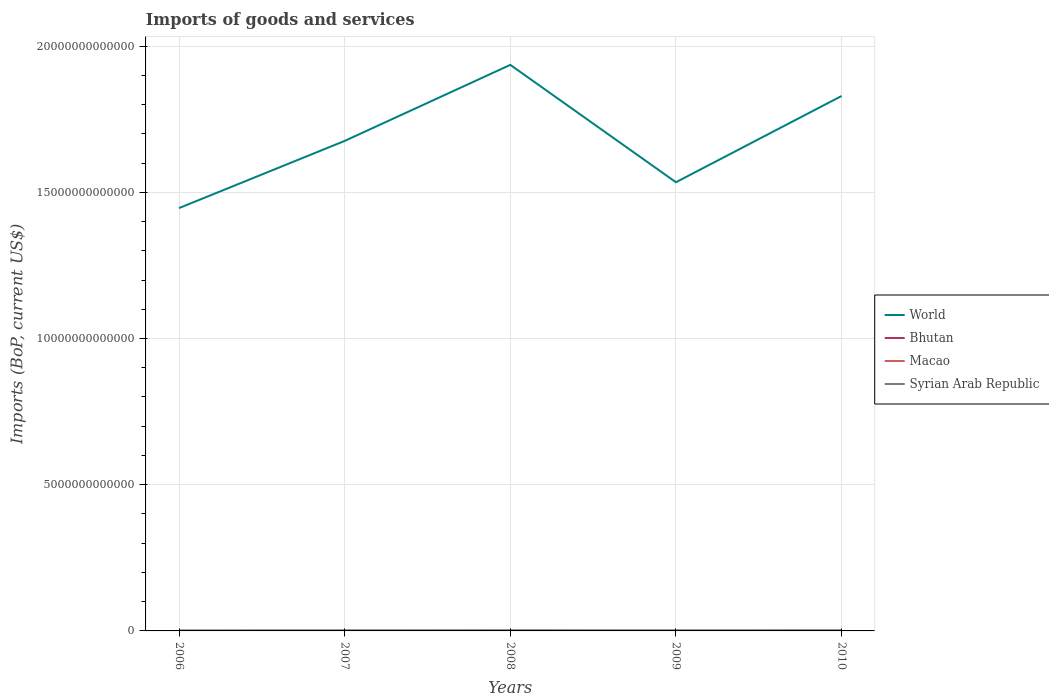How many different coloured lines are there?
Your response must be concise. 4. Does the line corresponding to Syrian Arab Republic intersect with the line corresponding to Macao?
Make the answer very short. No. Is the number of lines equal to the number of legend labels?
Offer a terse response. Yes. Across all years, what is the maximum amount spent on imports in Syrian Arab Republic?
Give a very brief answer. 1.19e+1. In which year was the amount spent on imports in Bhutan maximum?
Provide a succinct answer. 2006. What is the total amount spent on imports in Macao in the graph?
Give a very brief answer. -1.22e+09. What is the difference between the highest and the second highest amount spent on imports in Bhutan?
Keep it short and to the point. 4.36e+08. What is the difference between the highest and the lowest amount spent on imports in Macao?
Provide a short and direct response. 3. What is the difference between two consecutive major ticks on the Y-axis?
Offer a terse response. 5.00e+12. Does the graph contain any zero values?
Your answer should be compact. No. Where does the legend appear in the graph?
Keep it short and to the point. Center right. What is the title of the graph?
Provide a short and direct response. Imports of goods and services. Does "Virgin Islands" appear as one of the legend labels in the graph?
Ensure brevity in your answer.  No. What is the label or title of the Y-axis?
Give a very brief answer. Imports (BoP, current US$). What is the Imports (BoP, current US$) in World in 2006?
Keep it short and to the point. 1.45e+13. What is the Imports (BoP, current US$) of Bhutan in 2006?
Your answer should be compact. 4.99e+08. What is the Imports (BoP, current US$) in Macao in 2006?
Offer a very short reply. 8.92e+09. What is the Imports (BoP, current US$) of Syrian Arab Republic in 2006?
Ensure brevity in your answer.  1.19e+1. What is the Imports (BoP, current US$) of World in 2007?
Ensure brevity in your answer.  1.68e+13. What is the Imports (BoP, current US$) of Bhutan in 2007?
Your answer should be compact. 5.86e+08. What is the Imports (BoP, current US$) of Macao in 2007?
Give a very brief answer. 1.19e+1. What is the Imports (BoP, current US$) in Syrian Arab Republic in 2007?
Your answer should be very brief. 1.53e+1. What is the Imports (BoP, current US$) of World in 2008?
Ensure brevity in your answer.  1.94e+13. What is the Imports (BoP, current US$) in Bhutan in 2008?
Ensure brevity in your answer.  7.66e+08. What is the Imports (BoP, current US$) of Macao in 2008?
Keep it short and to the point. 1.31e+1. What is the Imports (BoP, current US$) of Syrian Arab Republic in 2008?
Make the answer very short. 1.93e+1. What is the Imports (BoP, current US$) of World in 2009?
Your answer should be very brief. 1.53e+13. What is the Imports (BoP, current US$) of Bhutan in 2009?
Give a very brief answer. 6.82e+08. What is the Imports (BoP, current US$) of Macao in 2009?
Offer a very short reply. 1.06e+1. What is the Imports (BoP, current US$) in Syrian Arab Republic in 2009?
Your answer should be compact. 1.67e+1. What is the Imports (BoP, current US$) of World in 2010?
Keep it short and to the point. 1.83e+13. What is the Imports (BoP, current US$) of Bhutan in 2010?
Give a very brief answer. 9.35e+08. What is the Imports (BoP, current US$) of Macao in 2010?
Make the answer very short. 1.41e+1. What is the Imports (BoP, current US$) of Syrian Arab Republic in 2010?
Your answer should be very brief. 1.94e+1. Across all years, what is the maximum Imports (BoP, current US$) in World?
Provide a succinct answer. 1.94e+13. Across all years, what is the maximum Imports (BoP, current US$) in Bhutan?
Give a very brief answer. 9.35e+08. Across all years, what is the maximum Imports (BoP, current US$) of Macao?
Provide a short and direct response. 1.41e+1. Across all years, what is the maximum Imports (BoP, current US$) of Syrian Arab Republic?
Offer a terse response. 1.94e+1. Across all years, what is the minimum Imports (BoP, current US$) in World?
Provide a short and direct response. 1.45e+13. Across all years, what is the minimum Imports (BoP, current US$) of Bhutan?
Offer a very short reply. 4.99e+08. Across all years, what is the minimum Imports (BoP, current US$) in Macao?
Your response must be concise. 8.92e+09. Across all years, what is the minimum Imports (BoP, current US$) of Syrian Arab Republic?
Offer a very short reply. 1.19e+1. What is the total Imports (BoP, current US$) in World in the graph?
Ensure brevity in your answer.  8.42e+13. What is the total Imports (BoP, current US$) in Bhutan in the graph?
Your answer should be compact. 3.47e+09. What is the total Imports (BoP, current US$) of Macao in the graph?
Give a very brief answer. 5.86e+1. What is the total Imports (BoP, current US$) of Syrian Arab Republic in the graph?
Offer a terse response. 8.25e+1. What is the difference between the Imports (BoP, current US$) in World in 2006 and that in 2007?
Your answer should be very brief. -2.30e+12. What is the difference between the Imports (BoP, current US$) of Bhutan in 2006 and that in 2007?
Ensure brevity in your answer.  -8.69e+07. What is the difference between the Imports (BoP, current US$) of Macao in 2006 and that in 2007?
Ensure brevity in your answer.  -2.97e+09. What is the difference between the Imports (BoP, current US$) of Syrian Arab Republic in 2006 and that in 2007?
Provide a short and direct response. -3.41e+09. What is the difference between the Imports (BoP, current US$) in World in 2006 and that in 2008?
Make the answer very short. -4.90e+12. What is the difference between the Imports (BoP, current US$) of Bhutan in 2006 and that in 2008?
Provide a short and direct response. -2.66e+08. What is the difference between the Imports (BoP, current US$) of Macao in 2006 and that in 2008?
Provide a short and direct response. -4.19e+09. What is the difference between the Imports (BoP, current US$) in Syrian Arab Republic in 2006 and that in 2008?
Give a very brief answer. -7.40e+09. What is the difference between the Imports (BoP, current US$) of World in 2006 and that in 2009?
Provide a short and direct response. -8.84e+11. What is the difference between the Imports (BoP, current US$) in Bhutan in 2006 and that in 2009?
Make the answer very short. -1.83e+08. What is the difference between the Imports (BoP, current US$) in Macao in 2006 and that in 2009?
Your answer should be very brief. -1.65e+09. What is the difference between the Imports (BoP, current US$) of Syrian Arab Republic in 2006 and that in 2009?
Ensure brevity in your answer.  -4.79e+09. What is the difference between the Imports (BoP, current US$) in World in 2006 and that in 2010?
Make the answer very short. -3.83e+12. What is the difference between the Imports (BoP, current US$) of Bhutan in 2006 and that in 2010?
Your response must be concise. -4.36e+08. What is the difference between the Imports (BoP, current US$) in Macao in 2006 and that in 2010?
Ensure brevity in your answer.  -5.21e+09. What is the difference between the Imports (BoP, current US$) of Syrian Arab Republic in 2006 and that in 2010?
Offer a very short reply. -7.53e+09. What is the difference between the Imports (BoP, current US$) in World in 2007 and that in 2008?
Ensure brevity in your answer.  -2.60e+12. What is the difference between the Imports (BoP, current US$) of Bhutan in 2007 and that in 2008?
Offer a terse response. -1.79e+08. What is the difference between the Imports (BoP, current US$) of Macao in 2007 and that in 2008?
Give a very brief answer. -1.22e+09. What is the difference between the Imports (BoP, current US$) in Syrian Arab Republic in 2007 and that in 2008?
Keep it short and to the point. -3.99e+09. What is the difference between the Imports (BoP, current US$) of World in 2007 and that in 2009?
Offer a very short reply. 1.41e+12. What is the difference between the Imports (BoP, current US$) in Bhutan in 2007 and that in 2009?
Keep it short and to the point. -9.58e+07. What is the difference between the Imports (BoP, current US$) in Macao in 2007 and that in 2009?
Your answer should be compact. 1.32e+09. What is the difference between the Imports (BoP, current US$) of Syrian Arab Republic in 2007 and that in 2009?
Give a very brief answer. -1.38e+09. What is the difference between the Imports (BoP, current US$) of World in 2007 and that in 2010?
Your answer should be compact. -1.54e+12. What is the difference between the Imports (BoP, current US$) in Bhutan in 2007 and that in 2010?
Provide a short and direct response. -3.49e+08. What is the difference between the Imports (BoP, current US$) in Macao in 2007 and that in 2010?
Offer a very short reply. -2.24e+09. What is the difference between the Imports (BoP, current US$) of Syrian Arab Republic in 2007 and that in 2010?
Provide a succinct answer. -4.12e+09. What is the difference between the Imports (BoP, current US$) of World in 2008 and that in 2009?
Provide a succinct answer. 4.01e+12. What is the difference between the Imports (BoP, current US$) of Bhutan in 2008 and that in 2009?
Make the answer very short. 8.35e+07. What is the difference between the Imports (BoP, current US$) of Macao in 2008 and that in 2009?
Make the answer very short. 2.55e+09. What is the difference between the Imports (BoP, current US$) in Syrian Arab Republic in 2008 and that in 2009?
Provide a short and direct response. 2.61e+09. What is the difference between the Imports (BoP, current US$) in World in 2008 and that in 2010?
Your answer should be compact. 1.06e+12. What is the difference between the Imports (BoP, current US$) in Bhutan in 2008 and that in 2010?
Your answer should be compact. -1.70e+08. What is the difference between the Imports (BoP, current US$) of Macao in 2008 and that in 2010?
Your response must be concise. -1.01e+09. What is the difference between the Imports (BoP, current US$) of Syrian Arab Republic in 2008 and that in 2010?
Ensure brevity in your answer.  -1.30e+08. What is the difference between the Imports (BoP, current US$) of World in 2009 and that in 2010?
Make the answer very short. -2.95e+12. What is the difference between the Imports (BoP, current US$) of Bhutan in 2009 and that in 2010?
Provide a short and direct response. -2.53e+08. What is the difference between the Imports (BoP, current US$) of Macao in 2009 and that in 2010?
Your answer should be very brief. -3.56e+09. What is the difference between the Imports (BoP, current US$) in Syrian Arab Republic in 2009 and that in 2010?
Make the answer very short. -2.74e+09. What is the difference between the Imports (BoP, current US$) in World in 2006 and the Imports (BoP, current US$) in Bhutan in 2007?
Your answer should be very brief. 1.45e+13. What is the difference between the Imports (BoP, current US$) in World in 2006 and the Imports (BoP, current US$) in Macao in 2007?
Your answer should be compact. 1.44e+13. What is the difference between the Imports (BoP, current US$) of World in 2006 and the Imports (BoP, current US$) of Syrian Arab Republic in 2007?
Provide a short and direct response. 1.44e+13. What is the difference between the Imports (BoP, current US$) in Bhutan in 2006 and the Imports (BoP, current US$) in Macao in 2007?
Provide a short and direct response. -1.14e+1. What is the difference between the Imports (BoP, current US$) in Bhutan in 2006 and the Imports (BoP, current US$) in Syrian Arab Republic in 2007?
Your answer should be very brief. -1.48e+1. What is the difference between the Imports (BoP, current US$) in Macao in 2006 and the Imports (BoP, current US$) in Syrian Arab Republic in 2007?
Your response must be concise. -6.37e+09. What is the difference between the Imports (BoP, current US$) in World in 2006 and the Imports (BoP, current US$) in Bhutan in 2008?
Offer a very short reply. 1.45e+13. What is the difference between the Imports (BoP, current US$) in World in 2006 and the Imports (BoP, current US$) in Macao in 2008?
Give a very brief answer. 1.44e+13. What is the difference between the Imports (BoP, current US$) in World in 2006 and the Imports (BoP, current US$) in Syrian Arab Republic in 2008?
Keep it short and to the point. 1.44e+13. What is the difference between the Imports (BoP, current US$) in Bhutan in 2006 and the Imports (BoP, current US$) in Macao in 2008?
Your answer should be very brief. -1.26e+1. What is the difference between the Imports (BoP, current US$) of Bhutan in 2006 and the Imports (BoP, current US$) of Syrian Arab Republic in 2008?
Make the answer very short. -1.88e+1. What is the difference between the Imports (BoP, current US$) of Macao in 2006 and the Imports (BoP, current US$) of Syrian Arab Republic in 2008?
Keep it short and to the point. -1.04e+1. What is the difference between the Imports (BoP, current US$) in World in 2006 and the Imports (BoP, current US$) in Bhutan in 2009?
Provide a succinct answer. 1.45e+13. What is the difference between the Imports (BoP, current US$) of World in 2006 and the Imports (BoP, current US$) of Macao in 2009?
Provide a short and direct response. 1.44e+13. What is the difference between the Imports (BoP, current US$) of World in 2006 and the Imports (BoP, current US$) of Syrian Arab Republic in 2009?
Your answer should be compact. 1.44e+13. What is the difference between the Imports (BoP, current US$) in Bhutan in 2006 and the Imports (BoP, current US$) in Macao in 2009?
Provide a succinct answer. -1.01e+1. What is the difference between the Imports (BoP, current US$) in Bhutan in 2006 and the Imports (BoP, current US$) in Syrian Arab Republic in 2009?
Your answer should be very brief. -1.62e+1. What is the difference between the Imports (BoP, current US$) in Macao in 2006 and the Imports (BoP, current US$) in Syrian Arab Republic in 2009?
Keep it short and to the point. -7.74e+09. What is the difference between the Imports (BoP, current US$) in World in 2006 and the Imports (BoP, current US$) in Bhutan in 2010?
Offer a very short reply. 1.45e+13. What is the difference between the Imports (BoP, current US$) in World in 2006 and the Imports (BoP, current US$) in Macao in 2010?
Provide a short and direct response. 1.44e+13. What is the difference between the Imports (BoP, current US$) of World in 2006 and the Imports (BoP, current US$) of Syrian Arab Republic in 2010?
Keep it short and to the point. 1.44e+13. What is the difference between the Imports (BoP, current US$) in Bhutan in 2006 and the Imports (BoP, current US$) in Macao in 2010?
Ensure brevity in your answer.  -1.36e+1. What is the difference between the Imports (BoP, current US$) in Bhutan in 2006 and the Imports (BoP, current US$) in Syrian Arab Republic in 2010?
Keep it short and to the point. -1.89e+1. What is the difference between the Imports (BoP, current US$) in Macao in 2006 and the Imports (BoP, current US$) in Syrian Arab Republic in 2010?
Provide a succinct answer. -1.05e+1. What is the difference between the Imports (BoP, current US$) in World in 2007 and the Imports (BoP, current US$) in Bhutan in 2008?
Make the answer very short. 1.68e+13. What is the difference between the Imports (BoP, current US$) of World in 2007 and the Imports (BoP, current US$) of Macao in 2008?
Provide a short and direct response. 1.67e+13. What is the difference between the Imports (BoP, current US$) of World in 2007 and the Imports (BoP, current US$) of Syrian Arab Republic in 2008?
Offer a very short reply. 1.67e+13. What is the difference between the Imports (BoP, current US$) of Bhutan in 2007 and the Imports (BoP, current US$) of Macao in 2008?
Your response must be concise. -1.25e+1. What is the difference between the Imports (BoP, current US$) of Bhutan in 2007 and the Imports (BoP, current US$) of Syrian Arab Republic in 2008?
Provide a succinct answer. -1.87e+1. What is the difference between the Imports (BoP, current US$) of Macao in 2007 and the Imports (BoP, current US$) of Syrian Arab Republic in 2008?
Provide a short and direct response. -7.39e+09. What is the difference between the Imports (BoP, current US$) in World in 2007 and the Imports (BoP, current US$) in Bhutan in 2009?
Your answer should be compact. 1.68e+13. What is the difference between the Imports (BoP, current US$) in World in 2007 and the Imports (BoP, current US$) in Macao in 2009?
Provide a short and direct response. 1.67e+13. What is the difference between the Imports (BoP, current US$) of World in 2007 and the Imports (BoP, current US$) of Syrian Arab Republic in 2009?
Your response must be concise. 1.67e+13. What is the difference between the Imports (BoP, current US$) in Bhutan in 2007 and the Imports (BoP, current US$) in Macao in 2009?
Provide a short and direct response. -9.98e+09. What is the difference between the Imports (BoP, current US$) of Bhutan in 2007 and the Imports (BoP, current US$) of Syrian Arab Republic in 2009?
Ensure brevity in your answer.  -1.61e+1. What is the difference between the Imports (BoP, current US$) of Macao in 2007 and the Imports (BoP, current US$) of Syrian Arab Republic in 2009?
Offer a terse response. -4.77e+09. What is the difference between the Imports (BoP, current US$) in World in 2007 and the Imports (BoP, current US$) in Bhutan in 2010?
Give a very brief answer. 1.68e+13. What is the difference between the Imports (BoP, current US$) in World in 2007 and the Imports (BoP, current US$) in Macao in 2010?
Your answer should be very brief. 1.67e+13. What is the difference between the Imports (BoP, current US$) in World in 2007 and the Imports (BoP, current US$) in Syrian Arab Republic in 2010?
Your answer should be compact. 1.67e+13. What is the difference between the Imports (BoP, current US$) in Bhutan in 2007 and the Imports (BoP, current US$) in Macao in 2010?
Ensure brevity in your answer.  -1.35e+1. What is the difference between the Imports (BoP, current US$) of Bhutan in 2007 and the Imports (BoP, current US$) of Syrian Arab Republic in 2010?
Offer a very short reply. -1.88e+1. What is the difference between the Imports (BoP, current US$) in Macao in 2007 and the Imports (BoP, current US$) in Syrian Arab Republic in 2010?
Your answer should be compact. -7.52e+09. What is the difference between the Imports (BoP, current US$) in World in 2008 and the Imports (BoP, current US$) in Bhutan in 2009?
Provide a succinct answer. 1.94e+13. What is the difference between the Imports (BoP, current US$) in World in 2008 and the Imports (BoP, current US$) in Macao in 2009?
Provide a short and direct response. 1.93e+13. What is the difference between the Imports (BoP, current US$) in World in 2008 and the Imports (BoP, current US$) in Syrian Arab Republic in 2009?
Keep it short and to the point. 1.93e+13. What is the difference between the Imports (BoP, current US$) of Bhutan in 2008 and the Imports (BoP, current US$) of Macao in 2009?
Provide a succinct answer. -9.80e+09. What is the difference between the Imports (BoP, current US$) of Bhutan in 2008 and the Imports (BoP, current US$) of Syrian Arab Republic in 2009?
Provide a succinct answer. -1.59e+1. What is the difference between the Imports (BoP, current US$) of Macao in 2008 and the Imports (BoP, current US$) of Syrian Arab Republic in 2009?
Offer a terse response. -3.55e+09. What is the difference between the Imports (BoP, current US$) in World in 2008 and the Imports (BoP, current US$) in Bhutan in 2010?
Provide a short and direct response. 1.94e+13. What is the difference between the Imports (BoP, current US$) in World in 2008 and the Imports (BoP, current US$) in Macao in 2010?
Your answer should be compact. 1.93e+13. What is the difference between the Imports (BoP, current US$) of World in 2008 and the Imports (BoP, current US$) of Syrian Arab Republic in 2010?
Make the answer very short. 1.93e+13. What is the difference between the Imports (BoP, current US$) of Bhutan in 2008 and the Imports (BoP, current US$) of Macao in 2010?
Keep it short and to the point. -1.34e+1. What is the difference between the Imports (BoP, current US$) of Bhutan in 2008 and the Imports (BoP, current US$) of Syrian Arab Republic in 2010?
Provide a short and direct response. -1.86e+1. What is the difference between the Imports (BoP, current US$) in Macao in 2008 and the Imports (BoP, current US$) in Syrian Arab Republic in 2010?
Make the answer very short. -6.29e+09. What is the difference between the Imports (BoP, current US$) in World in 2009 and the Imports (BoP, current US$) in Bhutan in 2010?
Your answer should be very brief. 1.53e+13. What is the difference between the Imports (BoP, current US$) of World in 2009 and the Imports (BoP, current US$) of Macao in 2010?
Your answer should be compact. 1.53e+13. What is the difference between the Imports (BoP, current US$) of World in 2009 and the Imports (BoP, current US$) of Syrian Arab Republic in 2010?
Give a very brief answer. 1.53e+13. What is the difference between the Imports (BoP, current US$) of Bhutan in 2009 and the Imports (BoP, current US$) of Macao in 2010?
Offer a terse response. -1.34e+1. What is the difference between the Imports (BoP, current US$) in Bhutan in 2009 and the Imports (BoP, current US$) in Syrian Arab Republic in 2010?
Make the answer very short. -1.87e+1. What is the difference between the Imports (BoP, current US$) in Macao in 2009 and the Imports (BoP, current US$) in Syrian Arab Republic in 2010?
Your answer should be compact. -8.84e+09. What is the average Imports (BoP, current US$) in World per year?
Keep it short and to the point. 1.68e+13. What is the average Imports (BoP, current US$) of Bhutan per year?
Make the answer very short. 6.94e+08. What is the average Imports (BoP, current US$) in Macao per year?
Provide a succinct answer. 1.17e+1. What is the average Imports (BoP, current US$) in Syrian Arab Republic per year?
Make the answer very short. 1.65e+1. In the year 2006, what is the difference between the Imports (BoP, current US$) of World and Imports (BoP, current US$) of Bhutan?
Your response must be concise. 1.45e+13. In the year 2006, what is the difference between the Imports (BoP, current US$) in World and Imports (BoP, current US$) in Macao?
Your response must be concise. 1.45e+13. In the year 2006, what is the difference between the Imports (BoP, current US$) in World and Imports (BoP, current US$) in Syrian Arab Republic?
Keep it short and to the point. 1.44e+13. In the year 2006, what is the difference between the Imports (BoP, current US$) in Bhutan and Imports (BoP, current US$) in Macao?
Make the answer very short. -8.42e+09. In the year 2006, what is the difference between the Imports (BoP, current US$) of Bhutan and Imports (BoP, current US$) of Syrian Arab Republic?
Provide a succinct answer. -1.14e+1. In the year 2006, what is the difference between the Imports (BoP, current US$) in Macao and Imports (BoP, current US$) in Syrian Arab Republic?
Provide a short and direct response. -2.96e+09. In the year 2007, what is the difference between the Imports (BoP, current US$) in World and Imports (BoP, current US$) in Bhutan?
Your response must be concise. 1.68e+13. In the year 2007, what is the difference between the Imports (BoP, current US$) of World and Imports (BoP, current US$) of Macao?
Give a very brief answer. 1.67e+13. In the year 2007, what is the difference between the Imports (BoP, current US$) in World and Imports (BoP, current US$) in Syrian Arab Republic?
Give a very brief answer. 1.67e+13. In the year 2007, what is the difference between the Imports (BoP, current US$) of Bhutan and Imports (BoP, current US$) of Macao?
Your response must be concise. -1.13e+1. In the year 2007, what is the difference between the Imports (BoP, current US$) of Bhutan and Imports (BoP, current US$) of Syrian Arab Republic?
Offer a very short reply. -1.47e+1. In the year 2007, what is the difference between the Imports (BoP, current US$) of Macao and Imports (BoP, current US$) of Syrian Arab Republic?
Your response must be concise. -3.40e+09. In the year 2008, what is the difference between the Imports (BoP, current US$) in World and Imports (BoP, current US$) in Bhutan?
Offer a very short reply. 1.94e+13. In the year 2008, what is the difference between the Imports (BoP, current US$) of World and Imports (BoP, current US$) of Macao?
Your answer should be very brief. 1.93e+13. In the year 2008, what is the difference between the Imports (BoP, current US$) in World and Imports (BoP, current US$) in Syrian Arab Republic?
Your answer should be very brief. 1.93e+13. In the year 2008, what is the difference between the Imports (BoP, current US$) in Bhutan and Imports (BoP, current US$) in Macao?
Give a very brief answer. -1.24e+1. In the year 2008, what is the difference between the Imports (BoP, current US$) of Bhutan and Imports (BoP, current US$) of Syrian Arab Republic?
Your answer should be compact. -1.85e+1. In the year 2008, what is the difference between the Imports (BoP, current US$) in Macao and Imports (BoP, current US$) in Syrian Arab Republic?
Provide a succinct answer. -6.16e+09. In the year 2009, what is the difference between the Imports (BoP, current US$) in World and Imports (BoP, current US$) in Bhutan?
Provide a succinct answer. 1.53e+13. In the year 2009, what is the difference between the Imports (BoP, current US$) of World and Imports (BoP, current US$) of Macao?
Provide a short and direct response. 1.53e+13. In the year 2009, what is the difference between the Imports (BoP, current US$) in World and Imports (BoP, current US$) in Syrian Arab Republic?
Give a very brief answer. 1.53e+13. In the year 2009, what is the difference between the Imports (BoP, current US$) of Bhutan and Imports (BoP, current US$) of Macao?
Provide a short and direct response. -9.89e+09. In the year 2009, what is the difference between the Imports (BoP, current US$) in Bhutan and Imports (BoP, current US$) in Syrian Arab Republic?
Provide a short and direct response. -1.60e+1. In the year 2009, what is the difference between the Imports (BoP, current US$) in Macao and Imports (BoP, current US$) in Syrian Arab Republic?
Provide a succinct answer. -6.10e+09. In the year 2010, what is the difference between the Imports (BoP, current US$) in World and Imports (BoP, current US$) in Bhutan?
Give a very brief answer. 1.83e+13. In the year 2010, what is the difference between the Imports (BoP, current US$) of World and Imports (BoP, current US$) of Macao?
Give a very brief answer. 1.83e+13. In the year 2010, what is the difference between the Imports (BoP, current US$) in World and Imports (BoP, current US$) in Syrian Arab Republic?
Your answer should be compact. 1.83e+13. In the year 2010, what is the difference between the Imports (BoP, current US$) of Bhutan and Imports (BoP, current US$) of Macao?
Make the answer very short. -1.32e+1. In the year 2010, what is the difference between the Imports (BoP, current US$) of Bhutan and Imports (BoP, current US$) of Syrian Arab Republic?
Provide a short and direct response. -1.85e+1. In the year 2010, what is the difference between the Imports (BoP, current US$) in Macao and Imports (BoP, current US$) in Syrian Arab Republic?
Make the answer very short. -5.28e+09. What is the ratio of the Imports (BoP, current US$) of World in 2006 to that in 2007?
Your response must be concise. 0.86. What is the ratio of the Imports (BoP, current US$) in Bhutan in 2006 to that in 2007?
Offer a very short reply. 0.85. What is the ratio of the Imports (BoP, current US$) in Macao in 2006 to that in 2007?
Offer a terse response. 0.75. What is the ratio of the Imports (BoP, current US$) of Syrian Arab Republic in 2006 to that in 2007?
Keep it short and to the point. 0.78. What is the ratio of the Imports (BoP, current US$) in World in 2006 to that in 2008?
Your answer should be compact. 0.75. What is the ratio of the Imports (BoP, current US$) of Bhutan in 2006 to that in 2008?
Offer a terse response. 0.65. What is the ratio of the Imports (BoP, current US$) of Macao in 2006 to that in 2008?
Provide a succinct answer. 0.68. What is the ratio of the Imports (BoP, current US$) of Syrian Arab Republic in 2006 to that in 2008?
Your answer should be very brief. 0.62. What is the ratio of the Imports (BoP, current US$) in World in 2006 to that in 2009?
Keep it short and to the point. 0.94. What is the ratio of the Imports (BoP, current US$) of Bhutan in 2006 to that in 2009?
Provide a short and direct response. 0.73. What is the ratio of the Imports (BoP, current US$) in Macao in 2006 to that in 2009?
Give a very brief answer. 0.84. What is the ratio of the Imports (BoP, current US$) in Syrian Arab Republic in 2006 to that in 2009?
Keep it short and to the point. 0.71. What is the ratio of the Imports (BoP, current US$) in World in 2006 to that in 2010?
Provide a short and direct response. 0.79. What is the ratio of the Imports (BoP, current US$) in Bhutan in 2006 to that in 2010?
Ensure brevity in your answer.  0.53. What is the ratio of the Imports (BoP, current US$) in Macao in 2006 to that in 2010?
Make the answer very short. 0.63. What is the ratio of the Imports (BoP, current US$) of Syrian Arab Republic in 2006 to that in 2010?
Your response must be concise. 0.61. What is the ratio of the Imports (BoP, current US$) in World in 2007 to that in 2008?
Give a very brief answer. 0.87. What is the ratio of the Imports (BoP, current US$) of Bhutan in 2007 to that in 2008?
Ensure brevity in your answer.  0.77. What is the ratio of the Imports (BoP, current US$) in Macao in 2007 to that in 2008?
Your response must be concise. 0.91. What is the ratio of the Imports (BoP, current US$) in Syrian Arab Republic in 2007 to that in 2008?
Ensure brevity in your answer.  0.79. What is the ratio of the Imports (BoP, current US$) of World in 2007 to that in 2009?
Your response must be concise. 1.09. What is the ratio of the Imports (BoP, current US$) of Bhutan in 2007 to that in 2009?
Provide a succinct answer. 0.86. What is the ratio of the Imports (BoP, current US$) in Macao in 2007 to that in 2009?
Your answer should be very brief. 1.13. What is the ratio of the Imports (BoP, current US$) in Syrian Arab Republic in 2007 to that in 2009?
Provide a succinct answer. 0.92. What is the ratio of the Imports (BoP, current US$) in World in 2007 to that in 2010?
Provide a short and direct response. 0.92. What is the ratio of the Imports (BoP, current US$) in Bhutan in 2007 to that in 2010?
Keep it short and to the point. 0.63. What is the ratio of the Imports (BoP, current US$) in Macao in 2007 to that in 2010?
Make the answer very short. 0.84. What is the ratio of the Imports (BoP, current US$) of Syrian Arab Republic in 2007 to that in 2010?
Provide a succinct answer. 0.79. What is the ratio of the Imports (BoP, current US$) of World in 2008 to that in 2009?
Ensure brevity in your answer.  1.26. What is the ratio of the Imports (BoP, current US$) in Bhutan in 2008 to that in 2009?
Offer a terse response. 1.12. What is the ratio of the Imports (BoP, current US$) in Macao in 2008 to that in 2009?
Offer a very short reply. 1.24. What is the ratio of the Imports (BoP, current US$) of Syrian Arab Republic in 2008 to that in 2009?
Make the answer very short. 1.16. What is the ratio of the Imports (BoP, current US$) in World in 2008 to that in 2010?
Provide a succinct answer. 1.06. What is the ratio of the Imports (BoP, current US$) of Bhutan in 2008 to that in 2010?
Your answer should be compact. 0.82. What is the ratio of the Imports (BoP, current US$) in Macao in 2008 to that in 2010?
Provide a succinct answer. 0.93. What is the ratio of the Imports (BoP, current US$) of World in 2009 to that in 2010?
Ensure brevity in your answer.  0.84. What is the ratio of the Imports (BoP, current US$) in Bhutan in 2009 to that in 2010?
Keep it short and to the point. 0.73. What is the ratio of the Imports (BoP, current US$) of Macao in 2009 to that in 2010?
Offer a very short reply. 0.75. What is the ratio of the Imports (BoP, current US$) in Syrian Arab Republic in 2009 to that in 2010?
Offer a terse response. 0.86. What is the difference between the highest and the second highest Imports (BoP, current US$) in World?
Offer a terse response. 1.06e+12. What is the difference between the highest and the second highest Imports (BoP, current US$) in Bhutan?
Your answer should be very brief. 1.70e+08. What is the difference between the highest and the second highest Imports (BoP, current US$) in Macao?
Provide a short and direct response. 1.01e+09. What is the difference between the highest and the second highest Imports (BoP, current US$) of Syrian Arab Republic?
Offer a very short reply. 1.30e+08. What is the difference between the highest and the lowest Imports (BoP, current US$) of World?
Ensure brevity in your answer.  4.90e+12. What is the difference between the highest and the lowest Imports (BoP, current US$) of Bhutan?
Offer a terse response. 4.36e+08. What is the difference between the highest and the lowest Imports (BoP, current US$) of Macao?
Your answer should be compact. 5.21e+09. What is the difference between the highest and the lowest Imports (BoP, current US$) of Syrian Arab Republic?
Provide a short and direct response. 7.53e+09. 